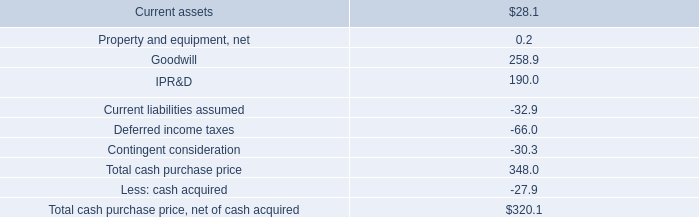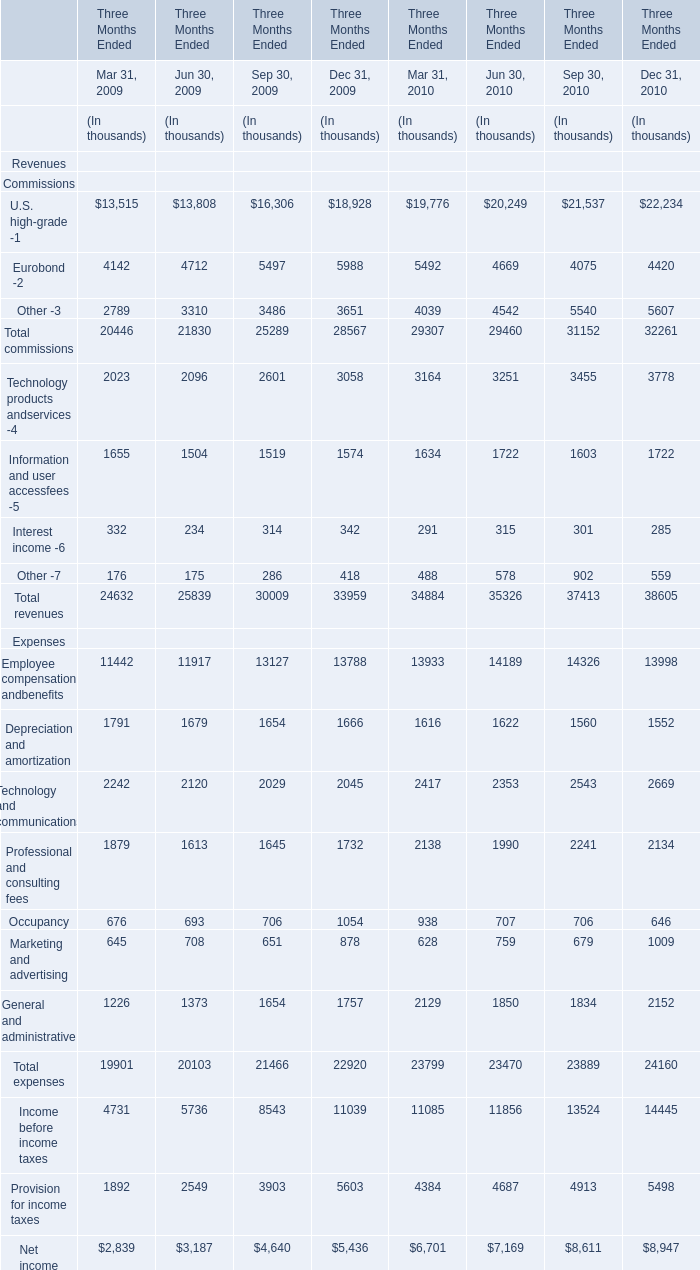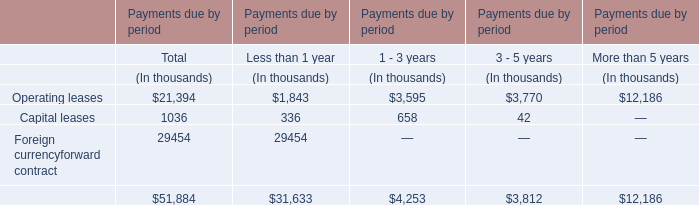What is the sum of Other -3 of Jun 30, 2009 for Three Months Ended and Capital leases for 1 - 3 years? (in thousand) 
Computations: (3310 + 658)
Answer: 3968.0. 